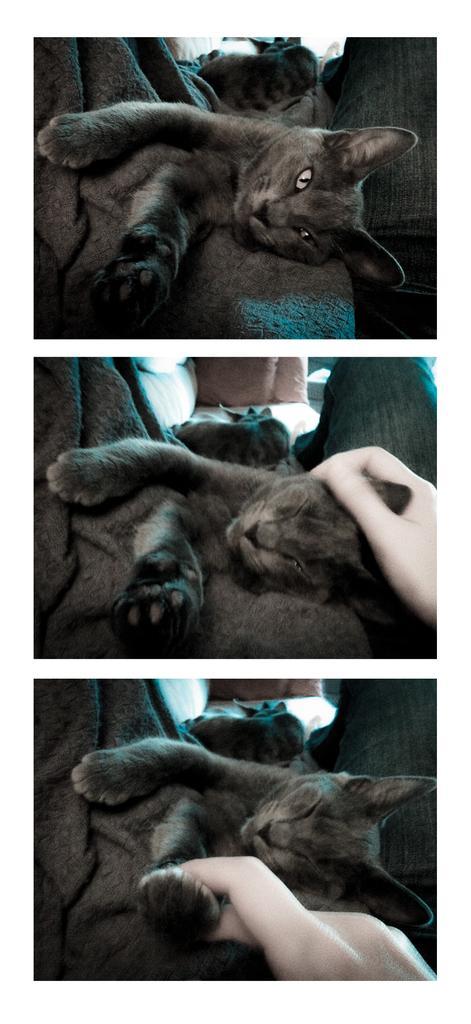How would you summarize this image in a sentence or two? In the picture we can see three images, in the first image we can see a cat lying on the bed and it is black and gray in color and in the second image we can see a cat sleeping on the bed and person hand touching its head and in the third image also we can see a cat is sleeping and a person hand holding a hand of the cat. 